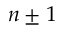Convert formula to latex. <formula><loc_0><loc_0><loc_500><loc_500>n \pm 1</formula> 